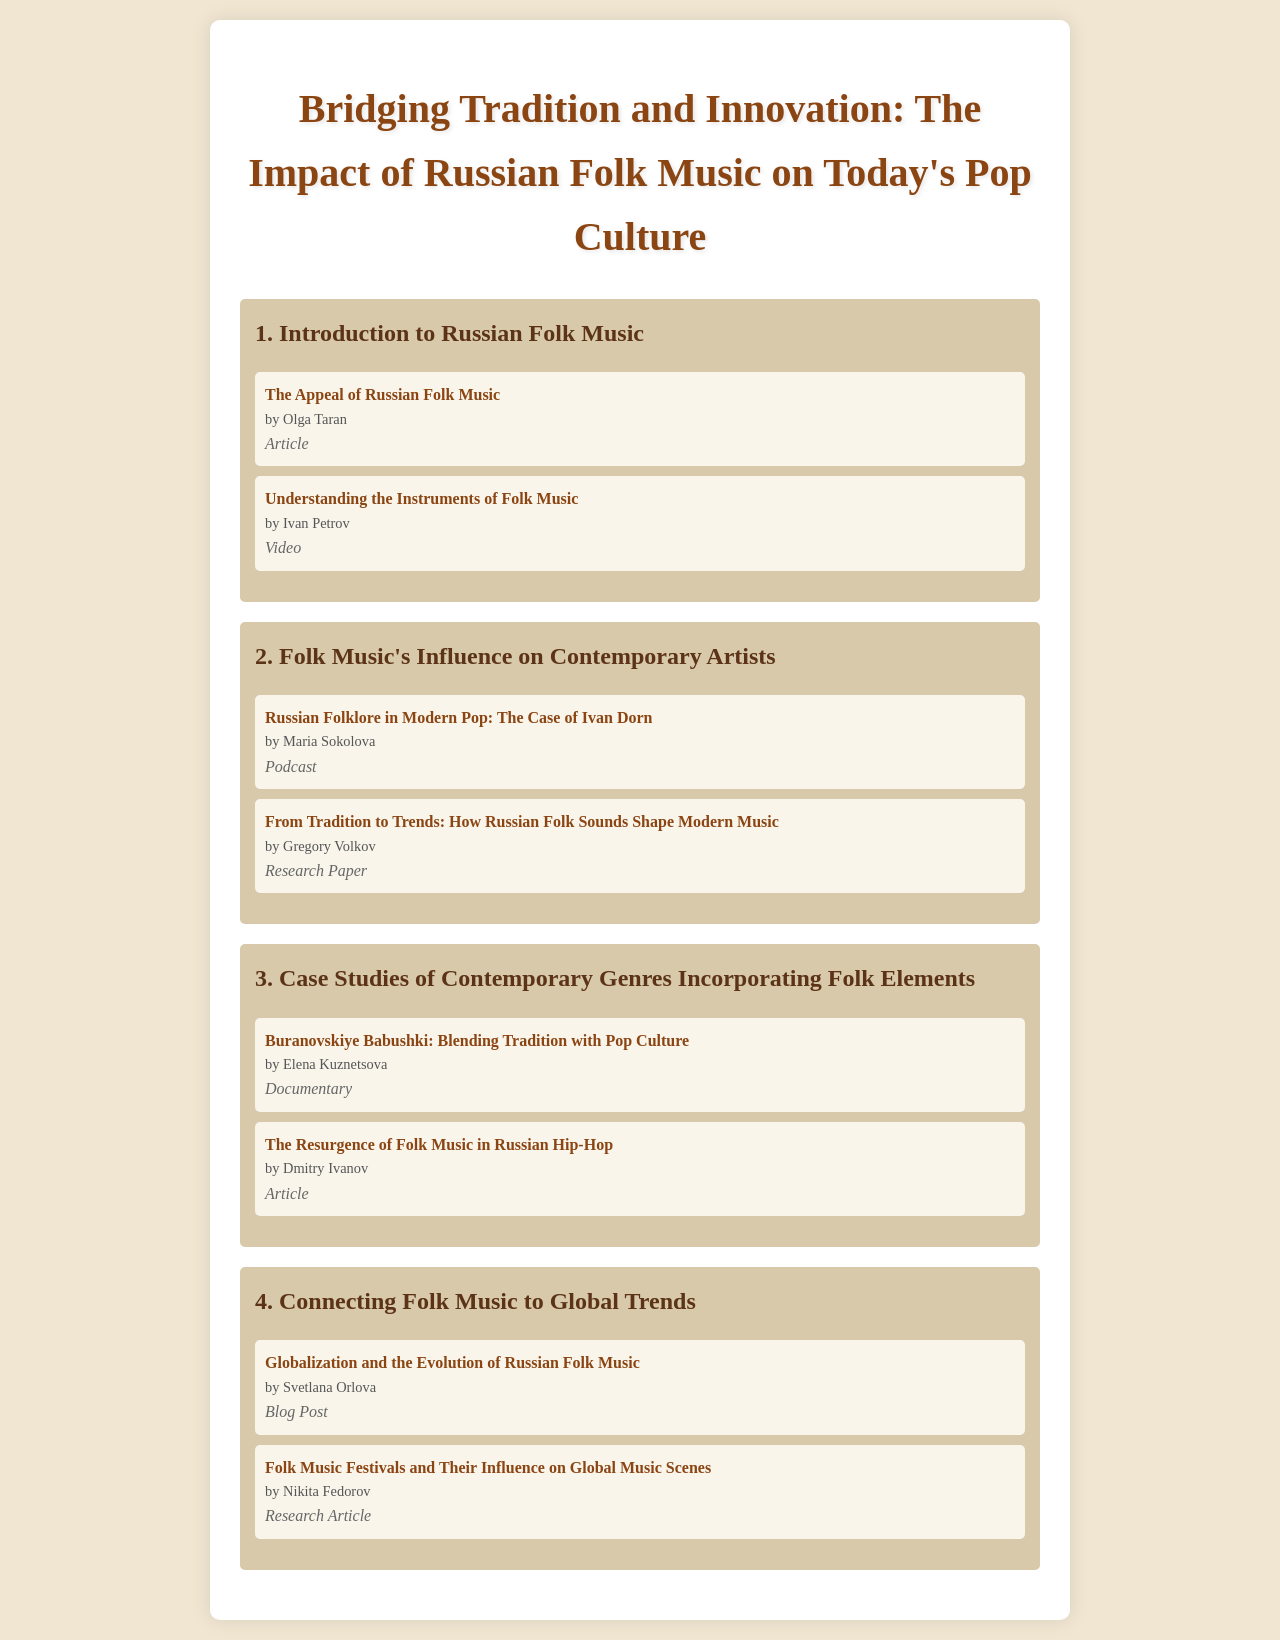What is the title of the schedule? The title is prominently displayed at the top of the document, indicating the main topic of discussion.
Answer: Bridging Tradition and Innovation: The Impact of Russian Folk Music on Today's Pop Culture Who authored "The Appeal of Russian Folk Music"? This article is listed under the first topic, providing the name of the author for reference.
Answer: Olga Taran What type of material is "Understanding the Instruments of Folk Music"? Each item in the list specifies the type of material, such as article, video, podcast, etc.
Answer: Video Which contemporary artist is discussed in relation to Russian folk music in a podcast? A specific podcast is mentioned in the document, highlighting the artist's connection to the theme.
Answer: Ivan Dorn How many topics are covered in the document? The document is divided into multiple sections, each representing a distinct topic.
Answer: Four What is a case study mentioned in the document related to pop culture blending with tradition? The document presents examples of contemporary genres that incorporate folk elements, including names.
Answer: Buranovskiye Babushki Who wrote the research article on the influence of folk music festivals? Each study or article is accompanied by the author's name; this question asks about a specific mention in the text.
Answer: Nikita Fedorov What is the main theme connecting folk music to global trends? This question targets the overarching concept present in one of the document's topics.
Answer: Globalization 